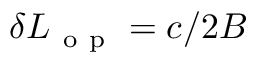Convert formula to latex. <formula><loc_0><loc_0><loc_500><loc_500>\delta L _ { o p } = c / 2 B</formula> 